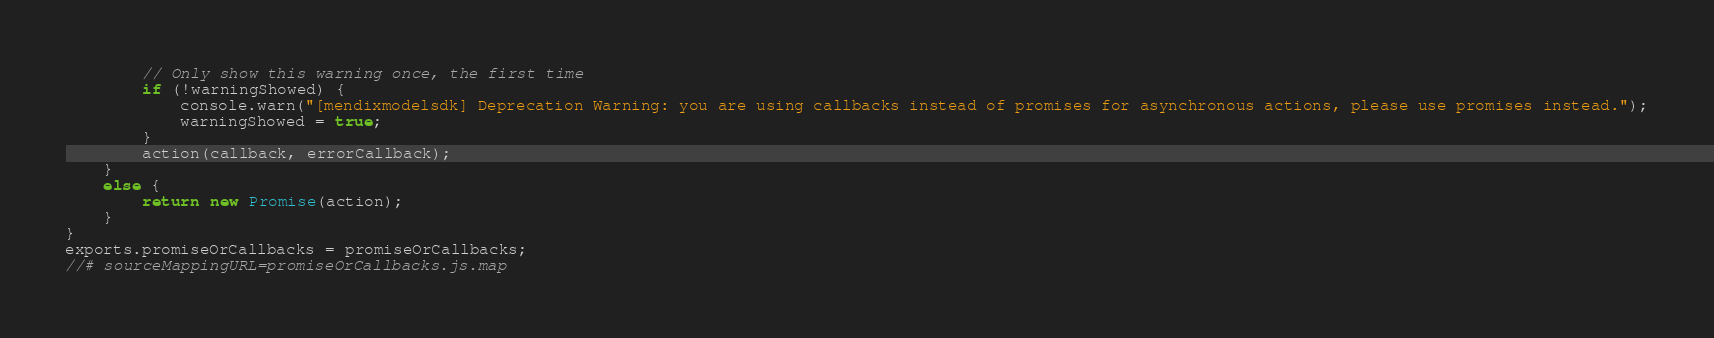<code> <loc_0><loc_0><loc_500><loc_500><_JavaScript_>        // Only show this warning once, the first time
        if (!warningShowed) {
            console.warn("[mendixmodelsdk] Deprecation Warning: you are using callbacks instead of promises for asynchronous actions, please use promises instead.");
            warningShowed = true;
        }
        action(callback, errorCallback);
    }
    else {
        return new Promise(action);
    }
}
exports.promiseOrCallbacks = promiseOrCallbacks;
//# sourceMappingURL=promiseOrCallbacks.js.map</code> 